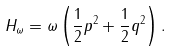Convert formula to latex. <formula><loc_0><loc_0><loc_500><loc_500>H _ { \omega } = \omega \left ( \frac { 1 } { 2 } p ^ { 2 } + \frac { 1 } { 2 } q ^ { 2 } \right ) .</formula> 